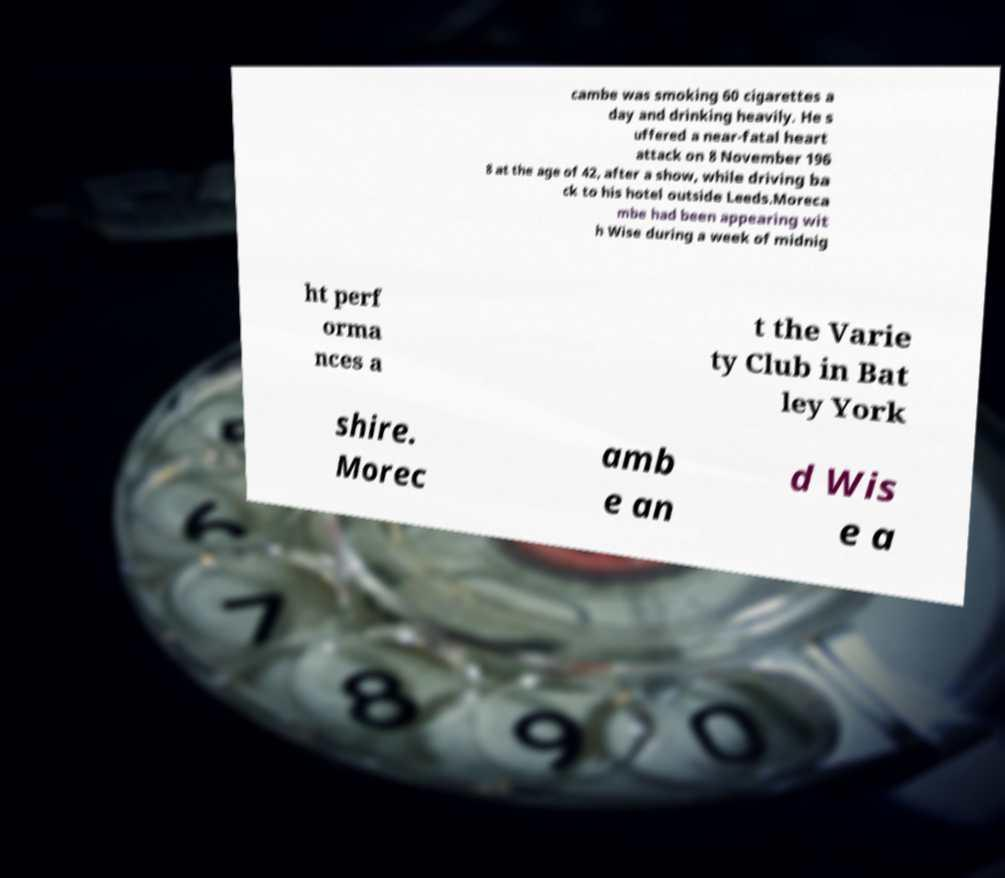For documentation purposes, I need the text within this image transcribed. Could you provide that? cambe was smoking 60 cigarettes a day and drinking heavily. He s uffered a near-fatal heart attack on 8 November 196 8 at the age of 42, after a show, while driving ba ck to his hotel outside Leeds.Moreca mbe had been appearing wit h Wise during a week of midnig ht perf orma nces a t the Varie ty Club in Bat ley York shire. Morec amb e an d Wis e a 